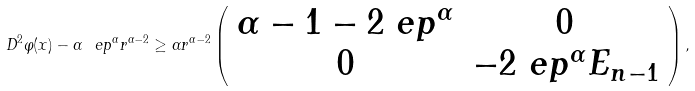<formula> <loc_0><loc_0><loc_500><loc_500>D ^ { 2 } \varphi ( x ) - \alpha \ e p ^ { \alpha } r ^ { \alpha - 2 } \geq \alpha r ^ { \alpha - 2 } \left ( \begin{array} { c c } \alpha - 1 - 2 \ e p ^ { \alpha } & 0 \\ 0 & - 2 \ e p ^ { \alpha } E _ { n - 1 } \end{array} \right ) ,</formula> 